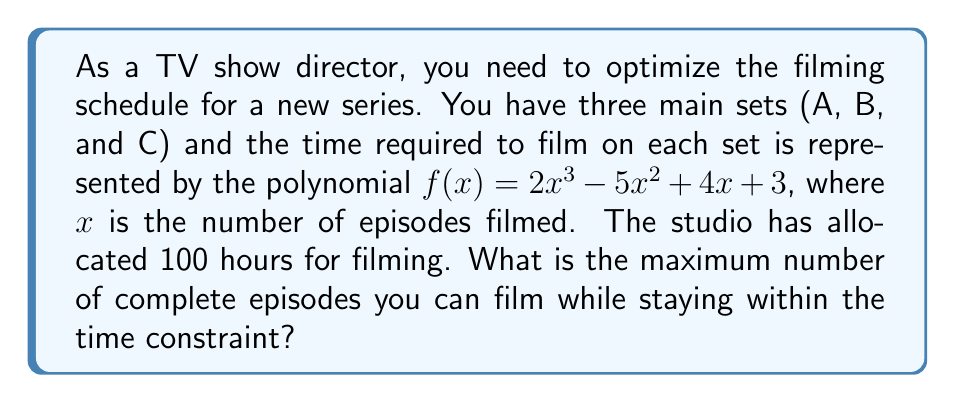Solve this math problem. To solve this problem, we need to use polynomial optimization techniques:

1) First, we need to find the cumulative time function. Since $f(x)$ represents the time for each episode, the total time for $x$ episodes is the sum of $f(1)$ to $f(x)$. This is represented by:

   $$F(x) = \sum_{i=1}^x f(i) = \sum_{i=1}^x (2i^3 - 5i^2 + 4i + 3)$$

2) Using the formulas for the sum of powers, we can simplify this to:

   $$F(x) = \frac{1}{2}x^4 - \frac{5}{6}x^3 + \frac{2}{3}x^2 + \frac{13}{6}x$$

3) Now, we need to find the largest value of $x$ such that $F(x) \leq 100$ (our time constraint).

4) We can solve this inequality:

   $$\frac{1}{2}x^4 - \frac{5}{6}x^3 + \frac{2}{3}x^2 + \frac{13}{6}x \leq 100$$

5) This is a complex inequality. We can solve it by testing integer values of $x$:

   For $x = 4$: $F(4) = 86$ (under 100)
   For $x = 5$: $F(5) = 164.17$ (over 100)

6) Therefore, the maximum number of complete episodes that can be filmed within 100 hours is 4.
Answer: 4 episodes 